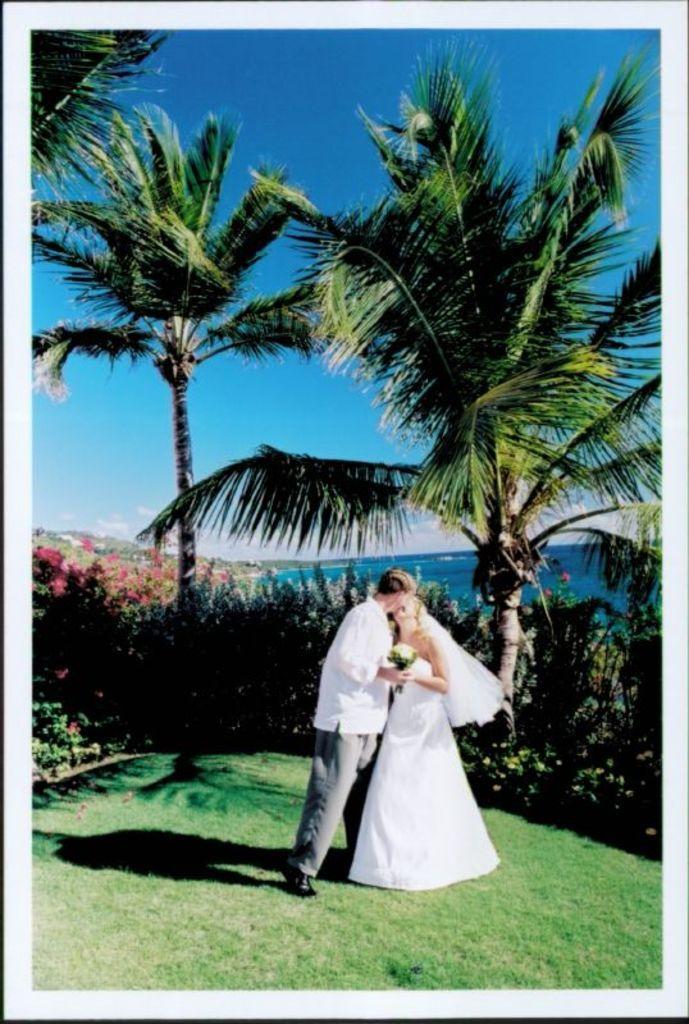Can you describe this image briefly? In this image there are couples, they are kissing in the background there are plants trees and a sea and there is a blue sky. 